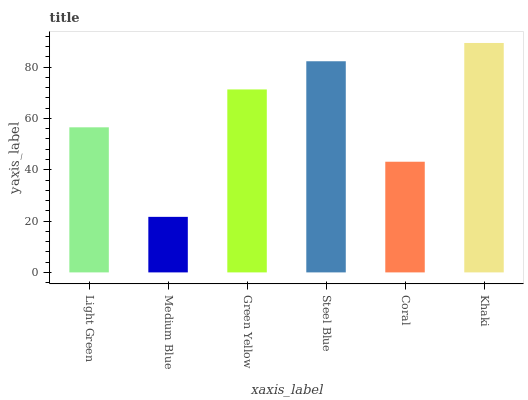Is Medium Blue the minimum?
Answer yes or no. Yes. Is Khaki the maximum?
Answer yes or no. Yes. Is Green Yellow the minimum?
Answer yes or no. No. Is Green Yellow the maximum?
Answer yes or no. No. Is Green Yellow greater than Medium Blue?
Answer yes or no. Yes. Is Medium Blue less than Green Yellow?
Answer yes or no. Yes. Is Medium Blue greater than Green Yellow?
Answer yes or no. No. Is Green Yellow less than Medium Blue?
Answer yes or no. No. Is Green Yellow the high median?
Answer yes or no. Yes. Is Light Green the low median?
Answer yes or no. Yes. Is Light Green the high median?
Answer yes or no. No. Is Khaki the low median?
Answer yes or no. No. 